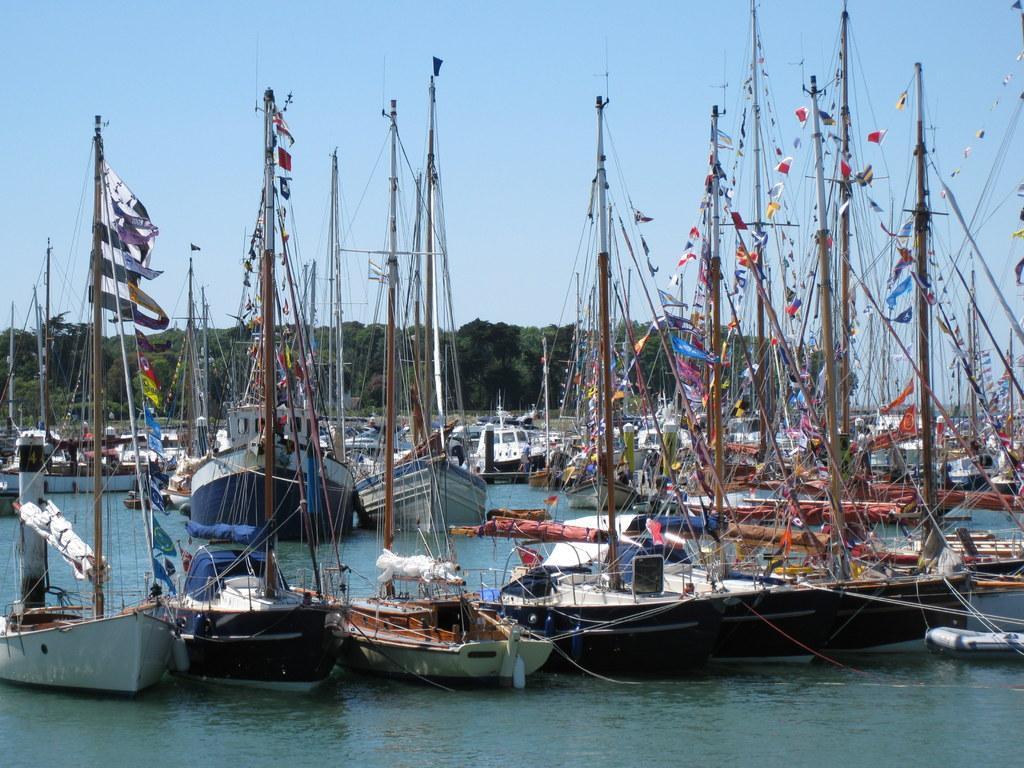In one or two sentences, can you explain what this image depicts? In this image there are boats in the water. In the background of the image there are trees and sky. 